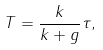Convert formula to latex. <formula><loc_0><loc_0><loc_500><loc_500>T = \frac { k } { k + g } \tau ,</formula> 